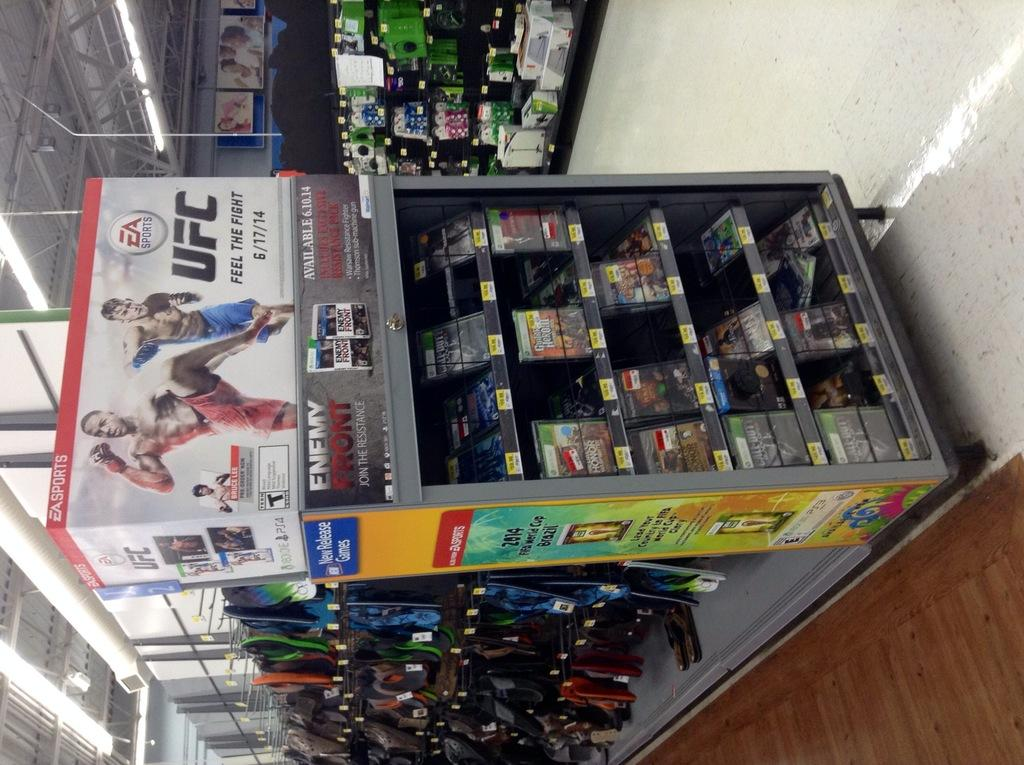Provide a one-sentence caption for the provided image. A box promoting an EA ultimate fighting game sits on top of a display in a store. 